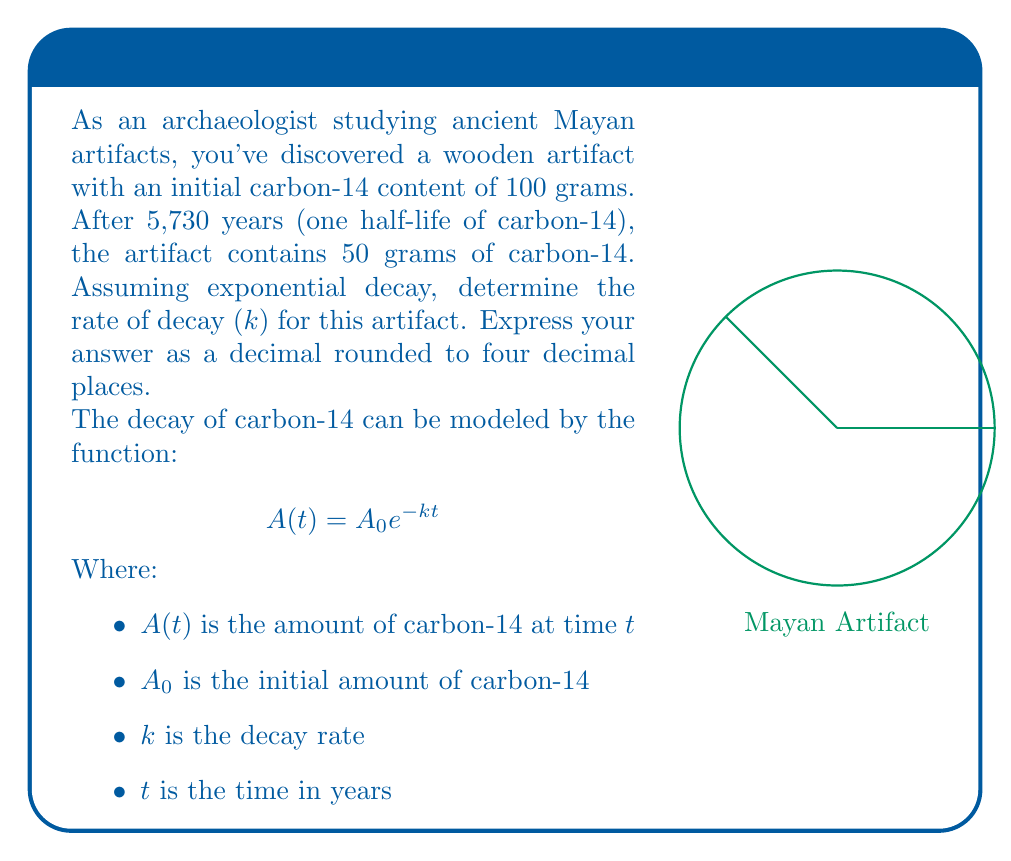Teach me how to tackle this problem. Let's solve this step-by-step:

1) We know that:
   $A_0 = 100$ grams (initial amount)
   $A(5730) = 50$ grams (amount after one half-life)
   $t = 5730$ years

2) We can plug these values into the exponential decay formula:
   $$ 50 = 100 e^{-k(5730)} $$

3) Divide both sides by 100:
   $$ \frac{1}{2} = e^{-5730k} $$

4) Take the natural log of both sides:
   $$ \ln(\frac{1}{2}) = -5730k $$

5) Solve for $k$:
   $$ k = -\frac{\ln(\frac{1}{2})}{5730} $$

6) Calculate:
   $$ k = -\frac{-0.69314718...}{5730} \approx 0.00012097... $$

7) Round to four decimal places:
   $$ k \approx 0.0001 $$

This means the carbon-14 in the artifact decays at a rate of approximately 0.01% per year.
Answer: $k \approx 0.0001$ 